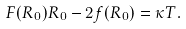Convert formula to latex. <formula><loc_0><loc_0><loc_500><loc_500>F ( R _ { 0 } ) R _ { 0 } - 2 f ( R _ { 0 } ) = \kappa T .</formula> 